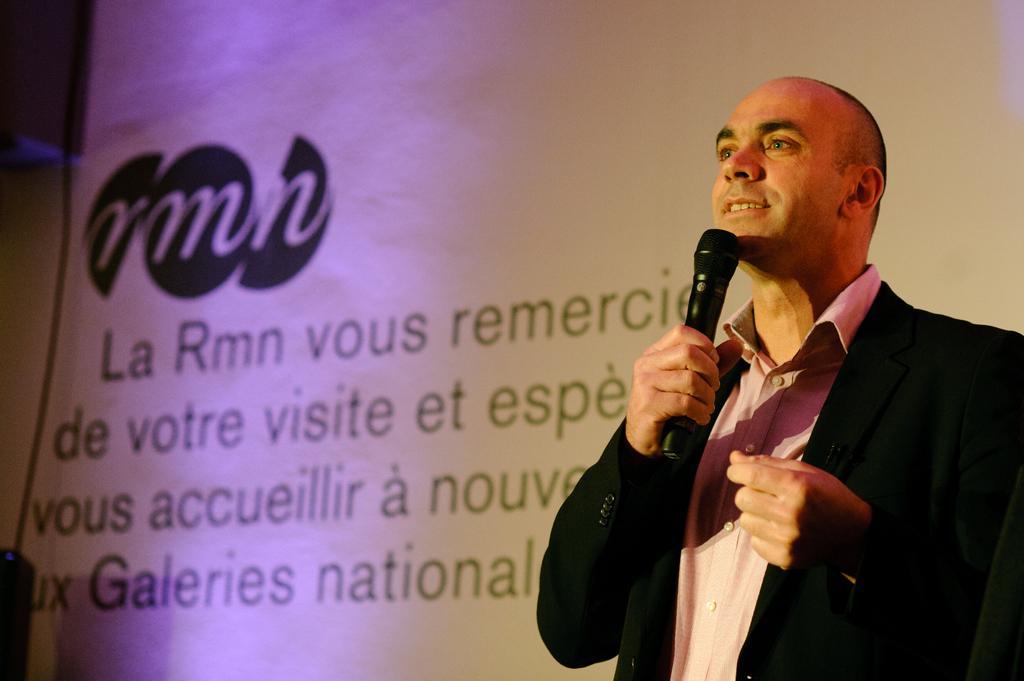How would you summarize this image in a sentence or two? This picture shows a man standing here, wearing a coat and holding a mic in his hand. He's smiling. In the background we can observe a screen with some sentences on it. 